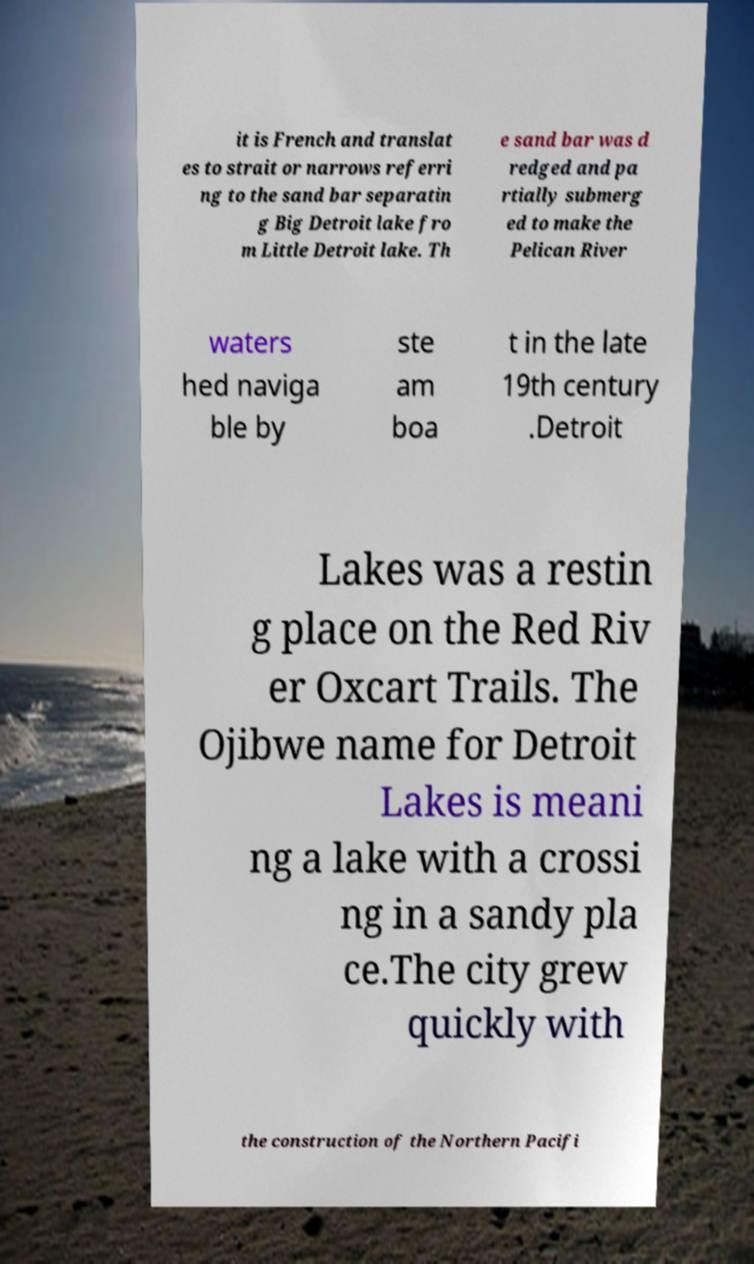What messages or text are displayed in this image? I need them in a readable, typed format. it is French and translat es to strait or narrows referri ng to the sand bar separatin g Big Detroit lake fro m Little Detroit lake. Th e sand bar was d redged and pa rtially submerg ed to make the Pelican River waters hed naviga ble by ste am boa t in the late 19th century .Detroit Lakes was a restin g place on the Red Riv er Oxcart Trails. The Ojibwe name for Detroit Lakes is meani ng a lake with a crossi ng in a sandy pla ce.The city grew quickly with the construction of the Northern Pacifi 